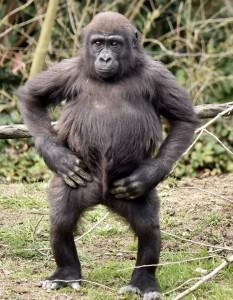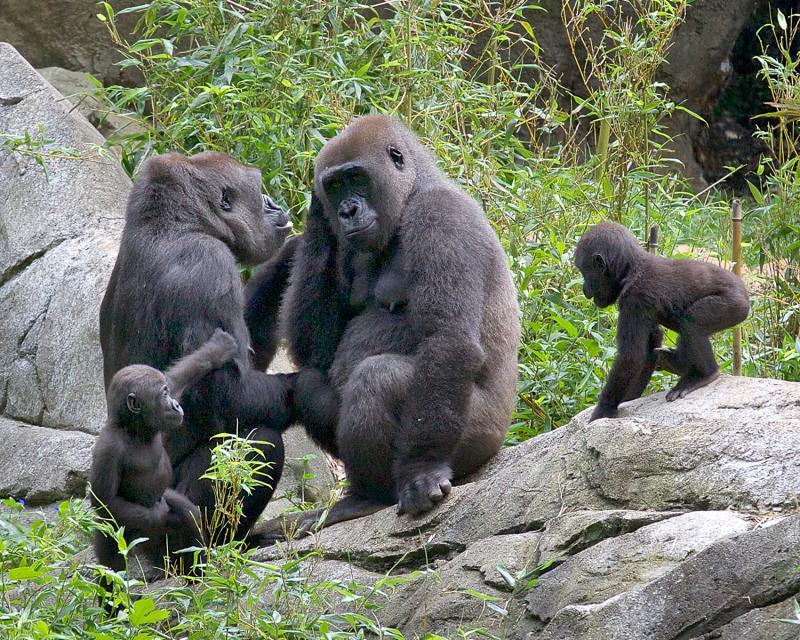The first image is the image on the left, the second image is the image on the right. Considering the images on both sides, is "There are monkeys on rocks in one of the images" valid? Answer yes or no. Yes. The first image is the image on the left, the second image is the image on the right. Considering the images on both sides, is "The image on the right shows exactly one adult gorilla." valid? Answer yes or no. No. 